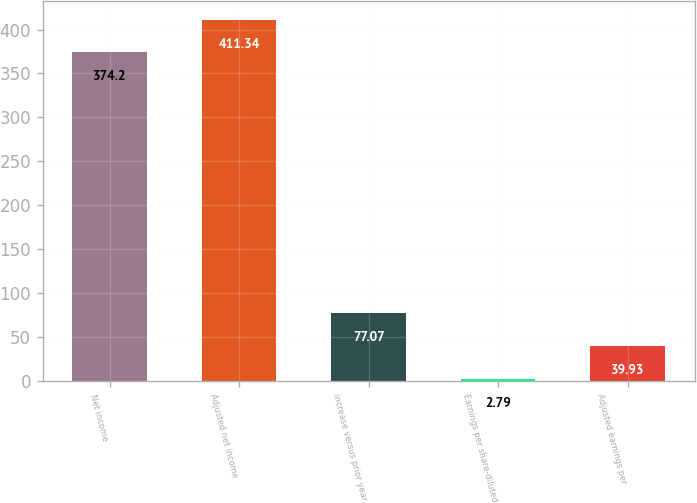<chart> <loc_0><loc_0><loc_500><loc_500><bar_chart><fcel>Net income<fcel>Adjusted net income<fcel>increase versus prior year<fcel>Earnings per share-diluted<fcel>Adjusted earnings per<nl><fcel>374.2<fcel>411.34<fcel>77.07<fcel>2.79<fcel>39.93<nl></chart> 